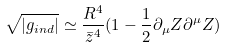Convert formula to latex. <formula><loc_0><loc_0><loc_500><loc_500>\sqrt { | g _ { i n d } | } \simeq \frac { R ^ { 4 } } { \bar { z } ^ { 4 } } ( 1 - \frac { 1 } { 2 } \partial _ { \mu } Z \partial ^ { \mu } Z )</formula> 